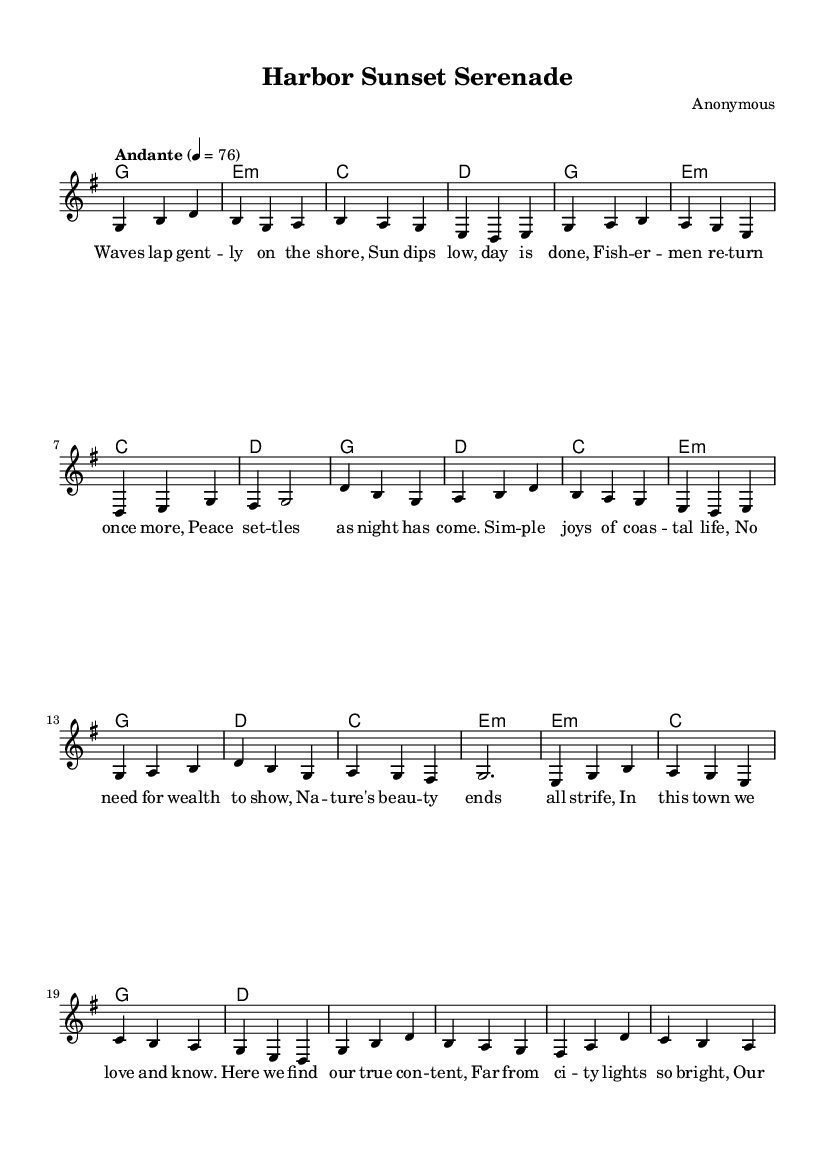What is the key signature of this music? The key signature is G major, which has one sharp (F#). This is indicated at the beginning of the sheet music.
Answer: G major What is the time signature of this piece? The time signature is 3/4, which indicates that there are three beats in each measure and the quarter note gets one beat. This is also shown at the beginning of the music.
Answer: 3/4 What is the tempo marking for this piece? The tempo marking is "Andante," which suggests a moderate pace. It is identified in the score immediately following the time signature.
Answer: Andante How many measures are in the verse section? The verse section consists of 8 measures. This can be counted by observing the melody notation, where each group of notes separated by bar lines represents a measure, totaling 8 for the verse.
Answer: 8 What primary musical emotion does this ballad convey? The primary emotion conveyed by this ballad is tranquility. This is inferred from the gentle melody and lyrics that celebrate the peaceful joys of coastal living, typical of Romantic music.
Answer: Tranquility How does the bridge differ from the verse and chorus musically? The bridge introduces some variation in harmonic structure, providing a contrast to the verse and chorus sections. It often features a different chord progression and may shift the melodic focus, enhancing emotional depth typical of Romantic ballads.
Answer: Variation 